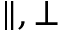Convert formula to latex. <formula><loc_0><loc_0><loc_500><loc_500>\| , \perp</formula> 